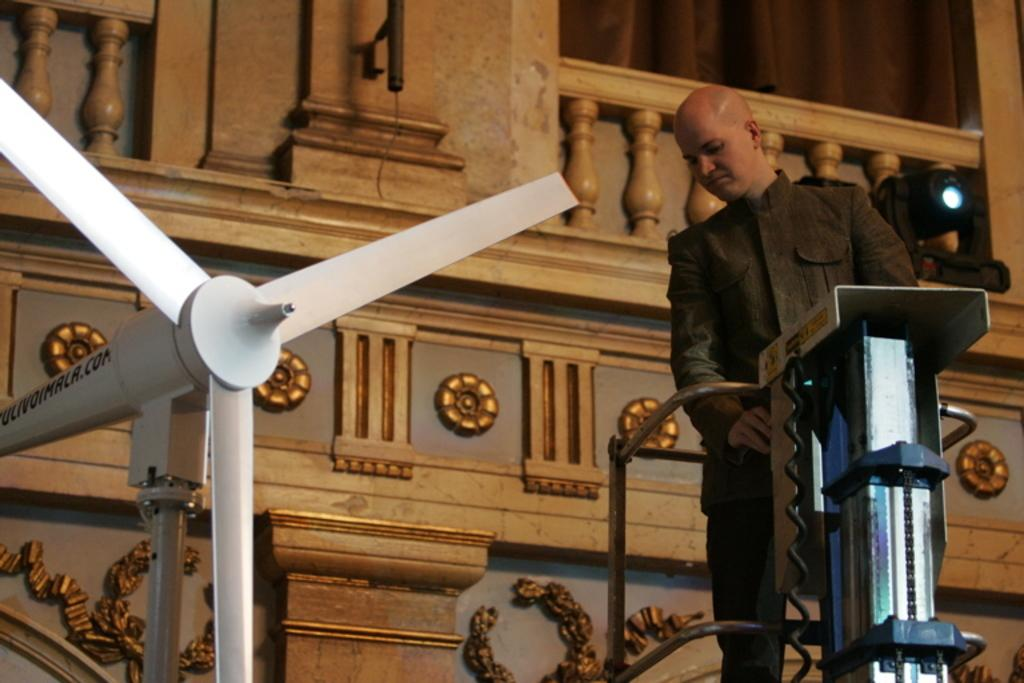What is the main subject of the image? There is a person in the image. What is the person doing in the image? The person is standing on a machine. What other object can be seen in the image? There is a fan in the image. How does the fan look like? The fan resembles a wind turbine. What type of watch can be seen on the person's wrist in the image? There is no watch visible on the person's wrist in the image. Is there a ship visible in the background of the image? There is no ship present in the image; it only features a person standing on a machine and a fan that resembles a wind turbine. 